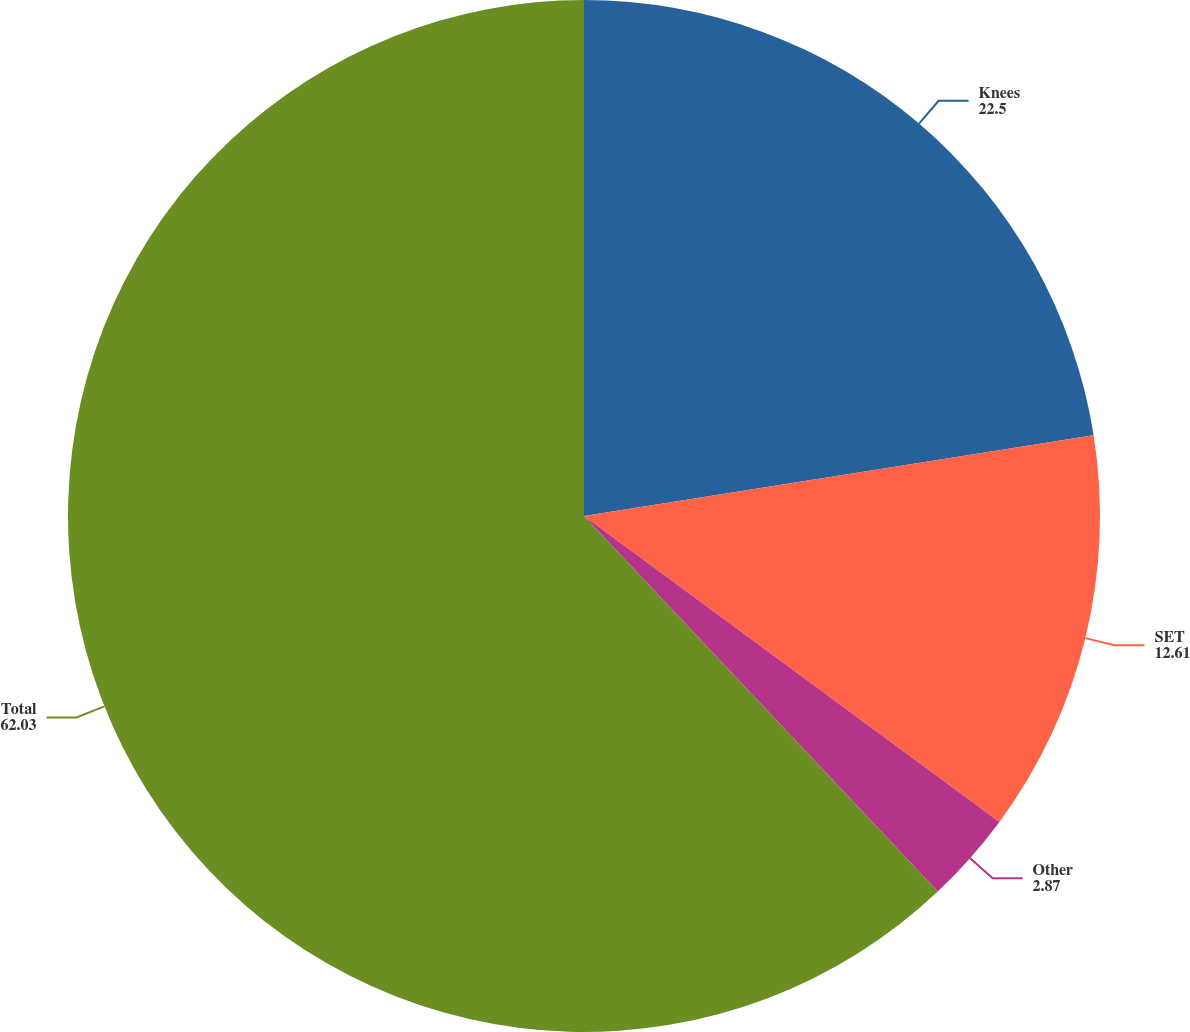<chart> <loc_0><loc_0><loc_500><loc_500><pie_chart><fcel>Knees<fcel>SET<fcel>Other<fcel>Total<nl><fcel>22.5%<fcel>12.61%<fcel>2.87%<fcel>62.03%<nl></chart> 